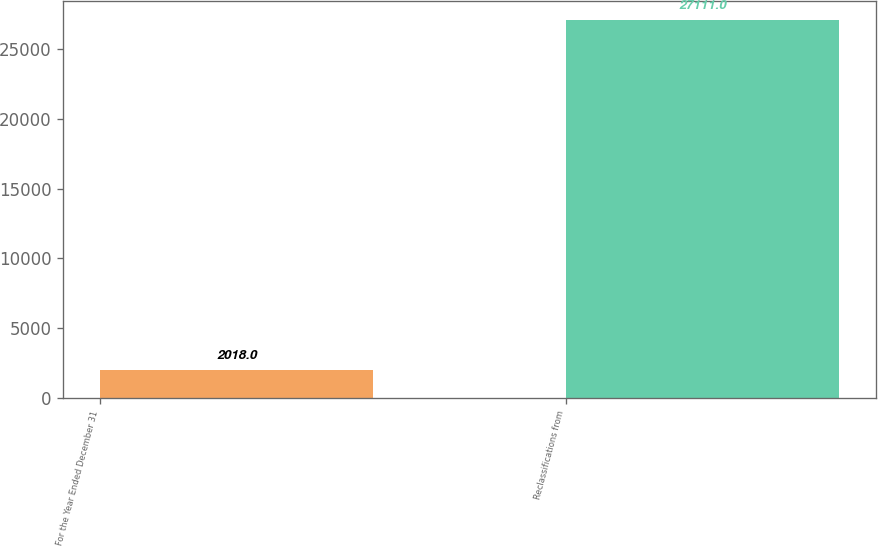Convert chart. <chart><loc_0><loc_0><loc_500><loc_500><bar_chart><fcel>For the Year Ended December 31<fcel>Reclassifications from<nl><fcel>2018<fcel>27111<nl></chart> 